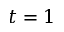<formula> <loc_0><loc_0><loc_500><loc_500>t = 1</formula> 